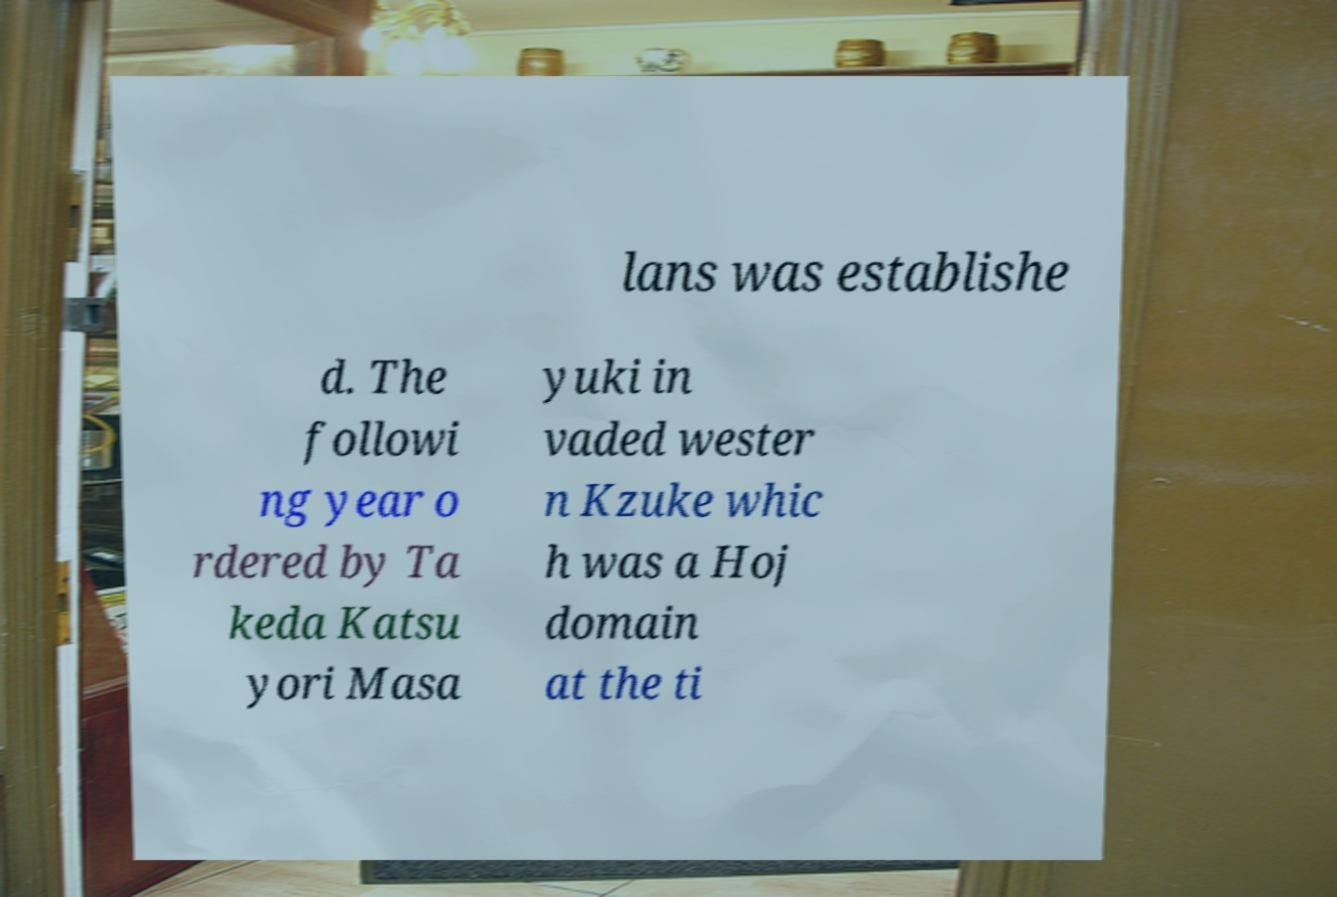I need the written content from this picture converted into text. Can you do that? lans was establishe d. The followi ng year o rdered by Ta keda Katsu yori Masa yuki in vaded wester n Kzuke whic h was a Hoj domain at the ti 